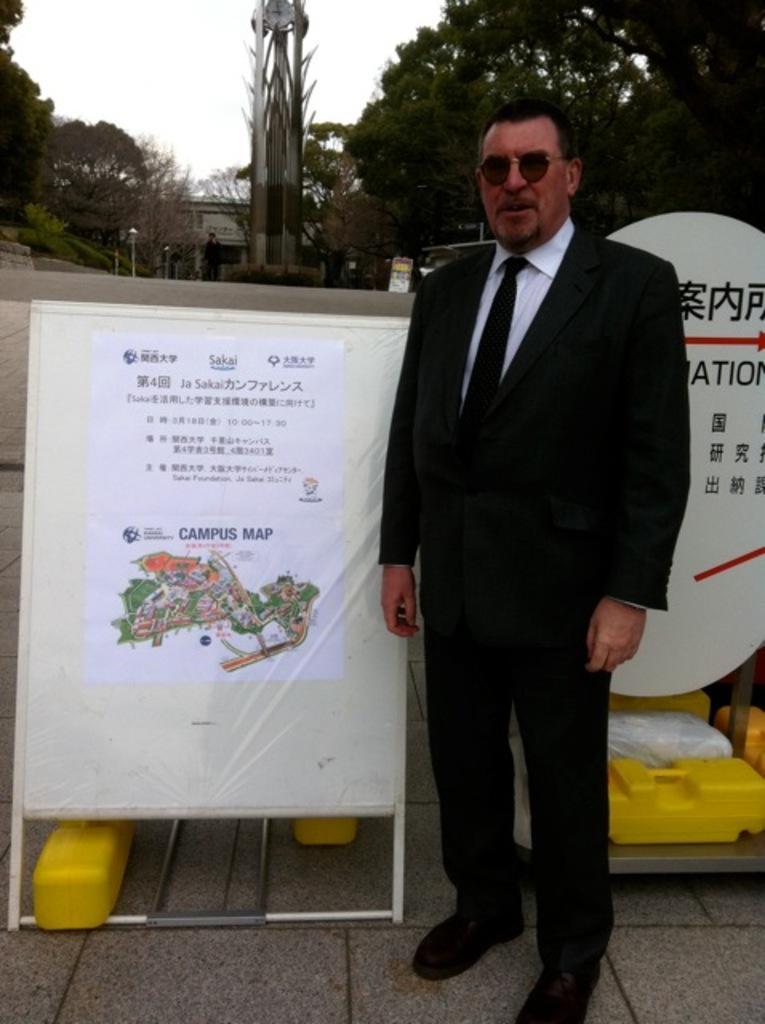Describe this image in one or two sentences. In this image I can see a person wearing white shirt, black tie and black colored dress is standing on the ground. I can see few banners which are white in color and few yellow colored objects behind him. In the background I can see few trees, few buildings, few poles, a tower with a clock on top of it, a person standing and the sky. 